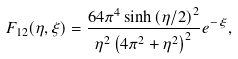<formula> <loc_0><loc_0><loc_500><loc_500>F _ { 1 2 } ( \eta , \xi ) = \frac { 6 4 \pi ^ { 4 } \sinh \left ( \eta / 2 \right ) ^ { 2 } } { \eta ^ { 2 } \left ( 4 \pi ^ { 2 } + \eta ^ { 2 } \right ) ^ { 2 } } e ^ { - \xi } ,</formula> 